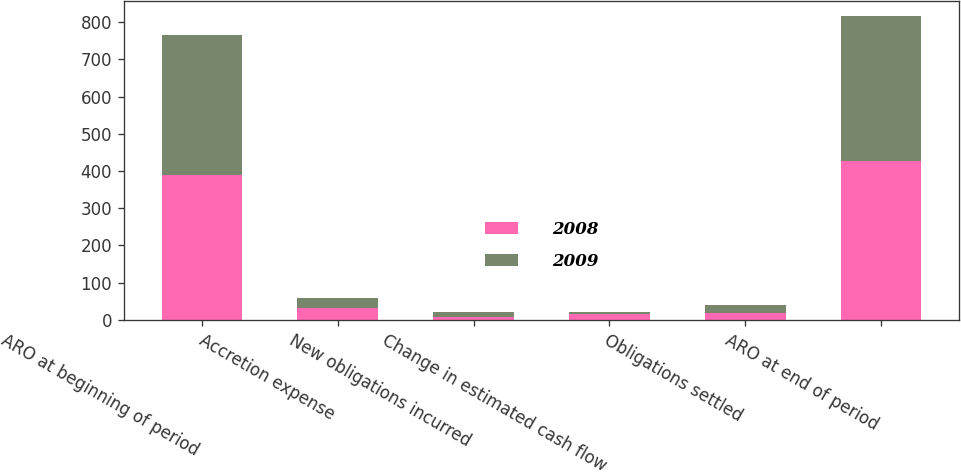Convert chart to OTSL. <chart><loc_0><loc_0><loc_500><loc_500><stacked_bar_chart><ecel><fcel>ARO at beginning of period<fcel>Accretion expense<fcel>New obligations incurred<fcel>Change in estimated cash flow<fcel>Obligations settled<fcel>ARO at end of period<nl><fcel>2008<fcel>389<fcel>31<fcel>9<fcel>16<fcel>19<fcel>426<nl><fcel>2009<fcel>376<fcel>29<fcel>12<fcel>4<fcel>22<fcel>389<nl></chart> 